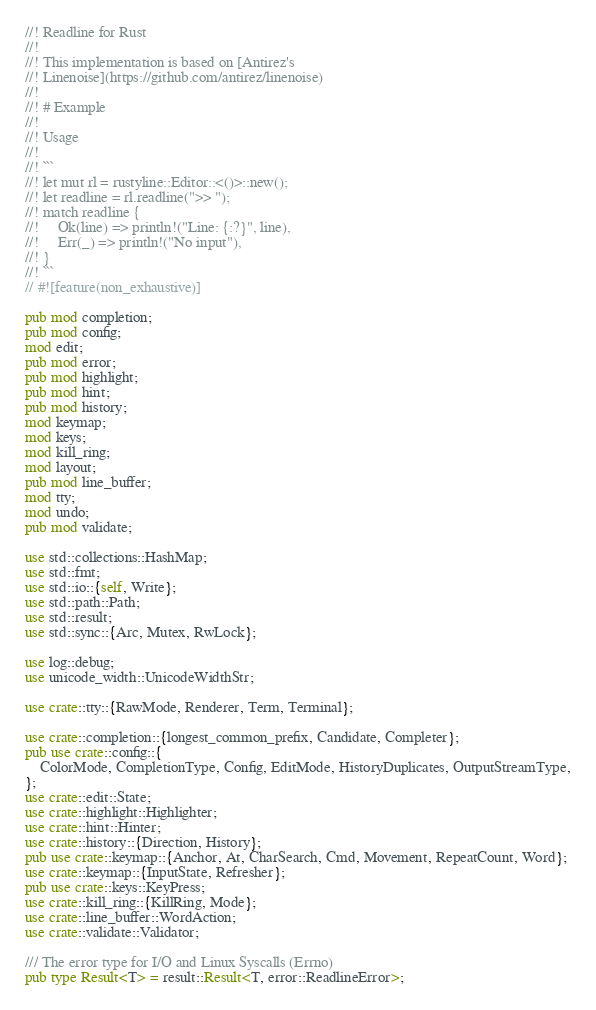Convert code to text. <code><loc_0><loc_0><loc_500><loc_500><_Rust_>//! Readline for Rust
//!
//! This implementation is based on [Antirez's
//! Linenoise](https://github.com/antirez/linenoise)
//!
//! # Example
//!
//! Usage
//!
//! ```
//! let mut rl = rustyline::Editor::<()>::new();
//! let readline = rl.readline(">> ");
//! match readline {
//!     Ok(line) => println!("Line: {:?}", line),
//!     Err(_) => println!("No input"),
//! }
//! ```
// #![feature(non_exhaustive)]

pub mod completion;
pub mod config;
mod edit;
pub mod error;
pub mod highlight;
pub mod hint;
pub mod history;
mod keymap;
mod keys;
mod kill_ring;
mod layout;
pub mod line_buffer;
mod tty;
mod undo;
pub mod validate;

use std::collections::HashMap;
use std::fmt;
use std::io::{self, Write};
use std::path::Path;
use std::result;
use std::sync::{Arc, Mutex, RwLock};

use log::debug;
use unicode_width::UnicodeWidthStr;

use crate::tty::{RawMode, Renderer, Term, Terminal};

use crate::completion::{longest_common_prefix, Candidate, Completer};
pub use crate::config::{
    ColorMode, CompletionType, Config, EditMode, HistoryDuplicates, OutputStreamType,
};
use crate::edit::State;
use crate::highlight::Highlighter;
use crate::hint::Hinter;
use crate::history::{Direction, History};
pub use crate::keymap::{Anchor, At, CharSearch, Cmd, Movement, RepeatCount, Word};
use crate::keymap::{InputState, Refresher};
pub use crate::keys::KeyPress;
use crate::kill_ring::{KillRing, Mode};
use crate::line_buffer::WordAction;
use crate::validate::Validator;

/// The error type for I/O and Linux Syscalls (Errno)
pub type Result<T> = result::Result<T, error::ReadlineError>;
</code> 